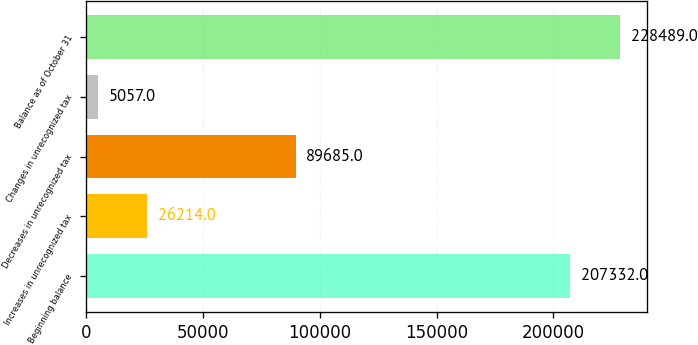Convert chart. <chart><loc_0><loc_0><loc_500><loc_500><bar_chart><fcel>Beginning balance<fcel>Increases in unrecognized tax<fcel>Decreases in unrecognized tax<fcel>Changes in unrecognized tax<fcel>Balance as of October 31<nl><fcel>207332<fcel>26214<fcel>89685<fcel>5057<fcel>228489<nl></chart> 